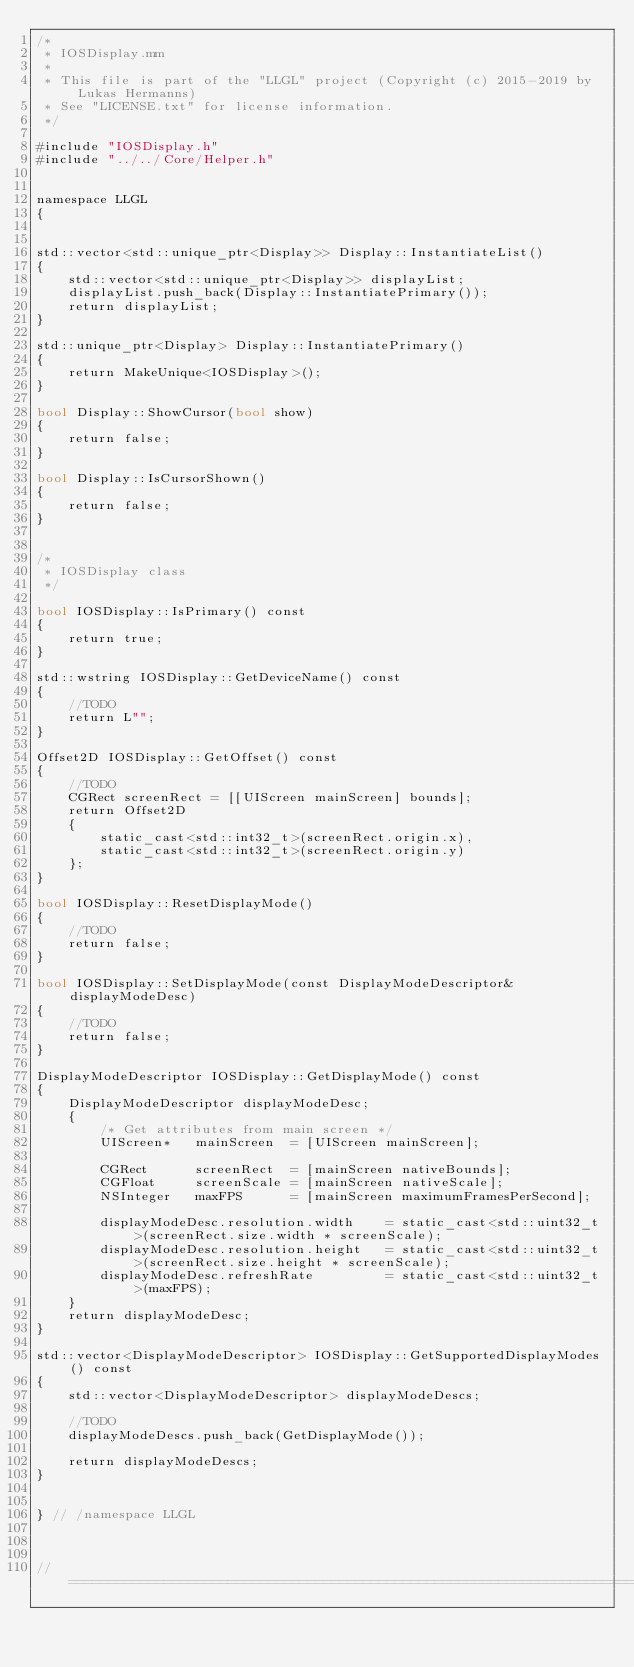<code> <loc_0><loc_0><loc_500><loc_500><_ObjectiveC_>/*
 * IOSDisplay.mm
 * 
 * This file is part of the "LLGL" project (Copyright (c) 2015-2019 by Lukas Hermanns)
 * See "LICENSE.txt" for license information.
 */

#include "IOSDisplay.h"
#include "../../Core/Helper.h"


namespace LLGL
{


std::vector<std::unique_ptr<Display>> Display::InstantiateList()
{
    std::vector<std::unique_ptr<Display>> displayList;
    displayList.push_back(Display::InstantiatePrimary());
    return displayList;
}

std::unique_ptr<Display> Display::InstantiatePrimary()
{
    return MakeUnique<IOSDisplay>();
}

bool Display::ShowCursor(bool show)
{
    return false;
}

bool Display::IsCursorShown()
{
    return false;
}


/*
 * IOSDisplay class
 */

bool IOSDisplay::IsPrimary() const
{
    return true;
}

std::wstring IOSDisplay::GetDeviceName() const
{
    //TODO
    return L"";
}

Offset2D IOSDisplay::GetOffset() const
{
    //TODO
    CGRect screenRect = [[UIScreen mainScreen] bounds];
    return Offset2D
    {
        static_cast<std::int32_t>(screenRect.origin.x),
        static_cast<std::int32_t>(screenRect.origin.y)
    };
}

bool IOSDisplay::ResetDisplayMode()
{
    //TODO
    return false;
}

bool IOSDisplay::SetDisplayMode(const DisplayModeDescriptor& displayModeDesc)
{
    //TODO
    return false;
}

DisplayModeDescriptor IOSDisplay::GetDisplayMode() const
{
    DisplayModeDescriptor displayModeDesc;
    {
        /* Get attributes from main screen */
        UIScreen*   mainScreen  = [UIScreen mainScreen];

        CGRect      screenRect  = [mainScreen nativeBounds];
        CGFloat     screenScale = [mainScreen nativeScale];
        NSInteger   maxFPS      = [mainScreen maximumFramesPerSecond];

        displayModeDesc.resolution.width    = static_cast<std::uint32_t>(screenRect.size.width * screenScale);
        displayModeDesc.resolution.height   = static_cast<std::uint32_t>(screenRect.size.height * screenScale);
        displayModeDesc.refreshRate         = static_cast<std::uint32_t>(maxFPS);
    }
    return displayModeDesc;
}

std::vector<DisplayModeDescriptor> IOSDisplay::GetSupportedDisplayModes() const
{
    std::vector<DisplayModeDescriptor> displayModeDescs;

    //TODO
    displayModeDescs.push_back(GetDisplayMode());

    return displayModeDescs;
}


} // /namespace LLGL



// ================================================================================
</code> 